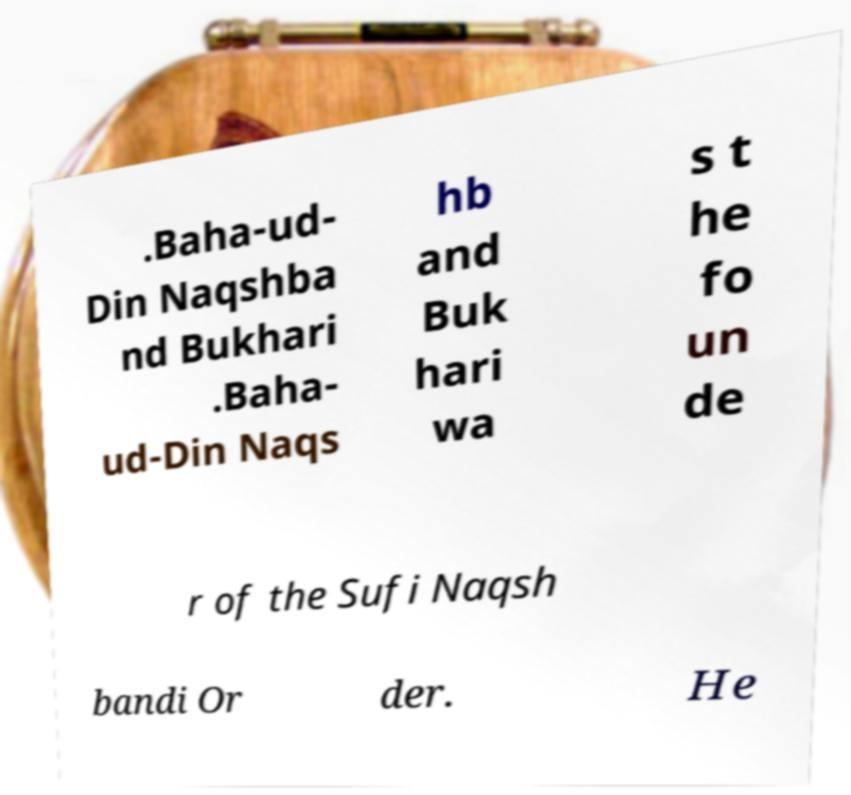Could you assist in decoding the text presented in this image and type it out clearly? .Baha-ud- Din Naqshba nd Bukhari .Baha- ud-Din Naqs hb and Buk hari wa s t he fo un de r of the Sufi Naqsh bandi Or der. He 